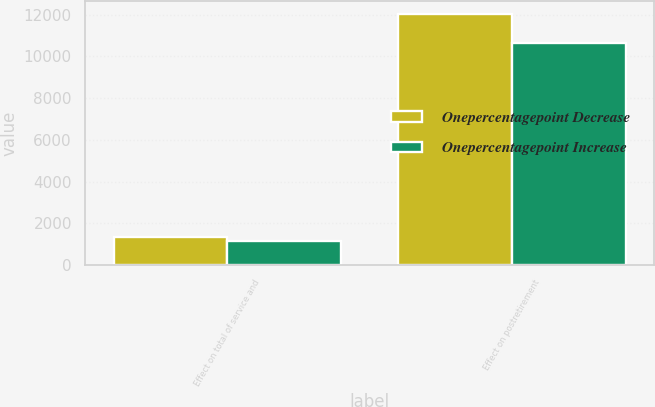<chart> <loc_0><loc_0><loc_500><loc_500><stacked_bar_chart><ecel><fcel>Effect on total of service and<fcel>Effect on postretirement<nl><fcel>Onepercentagepoint Decrease<fcel>1326<fcel>12043<nl><fcel>Onepercentagepoint Increase<fcel>1146<fcel>10653<nl></chart> 